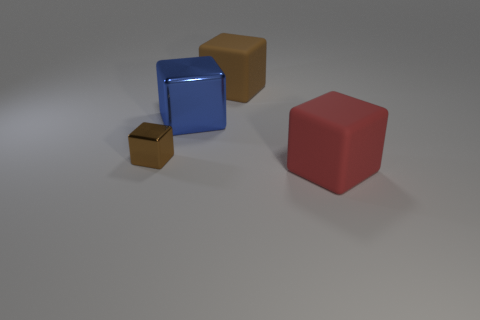Subtract 1 cubes. How many cubes are left? 3 Add 3 objects. How many objects exist? 7 Add 4 small things. How many small things exist? 5 Subtract 0 cyan balls. How many objects are left? 4 Subtract all brown matte blocks. Subtract all tiny cyan shiny balls. How many objects are left? 3 Add 2 large brown matte blocks. How many large brown matte blocks are left? 3 